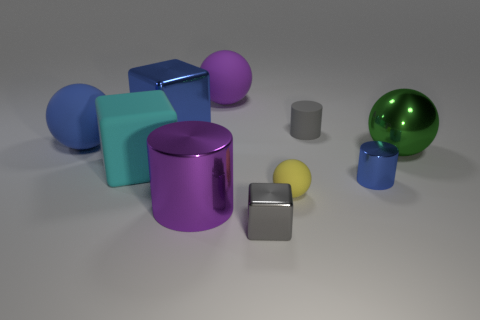Subtract all cylinders. How many objects are left? 7 Subtract 0 gray spheres. How many objects are left? 10 Subtract all blue shiny cylinders. Subtract all tiny cylinders. How many objects are left? 7 Add 7 small shiny blocks. How many small shiny blocks are left? 8 Add 5 large purple shiny things. How many large purple shiny things exist? 6 